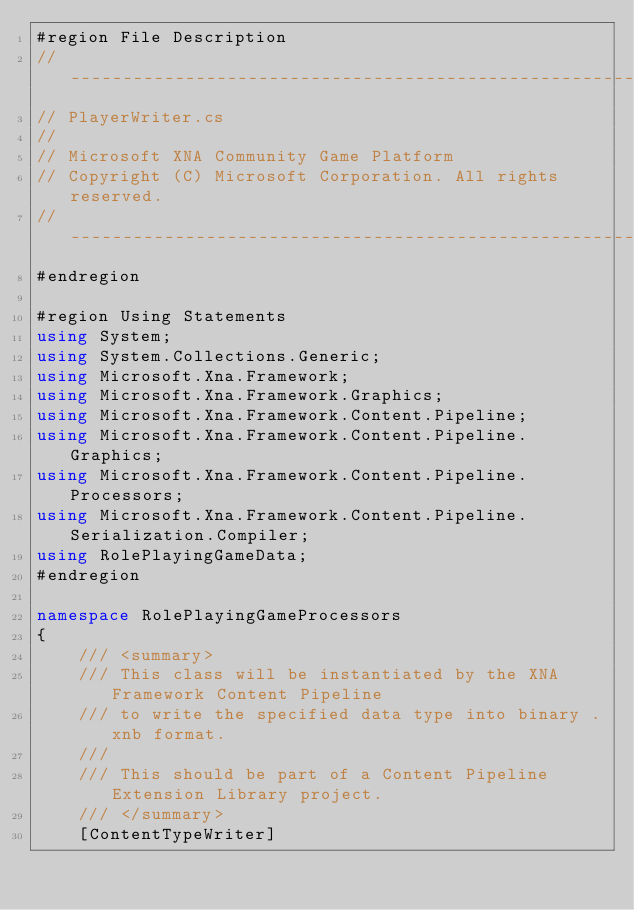Convert code to text. <code><loc_0><loc_0><loc_500><loc_500><_C#_>#region File Description
//-----------------------------------------------------------------------------
// PlayerWriter.cs
//
// Microsoft XNA Community Game Platform
// Copyright (C) Microsoft Corporation. All rights reserved.
//-----------------------------------------------------------------------------
#endregion

#region Using Statements
using System;
using System.Collections.Generic;
using Microsoft.Xna.Framework;
using Microsoft.Xna.Framework.Graphics;
using Microsoft.Xna.Framework.Content.Pipeline;
using Microsoft.Xna.Framework.Content.Pipeline.Graphics;
using Microsoft.Xna.Framework.Content.Pipeline.Processors;
using Microsoft.Xna.Framework.Content.Pipeline.Serialization.Compiler;
using RolePlayingGameData;
#endregion

namespace RolePlayingGameProcessors
{
    /// <summary>
    /// This class will be instantiated by the XNA Framework Content Pipeline
    /// to write the specified data type into binary .xnb format.
    ///
    /// This should be part of a Content Pipeline Extension Library project.
    /// </summary>
    [ContentTypeWriter]</code> 